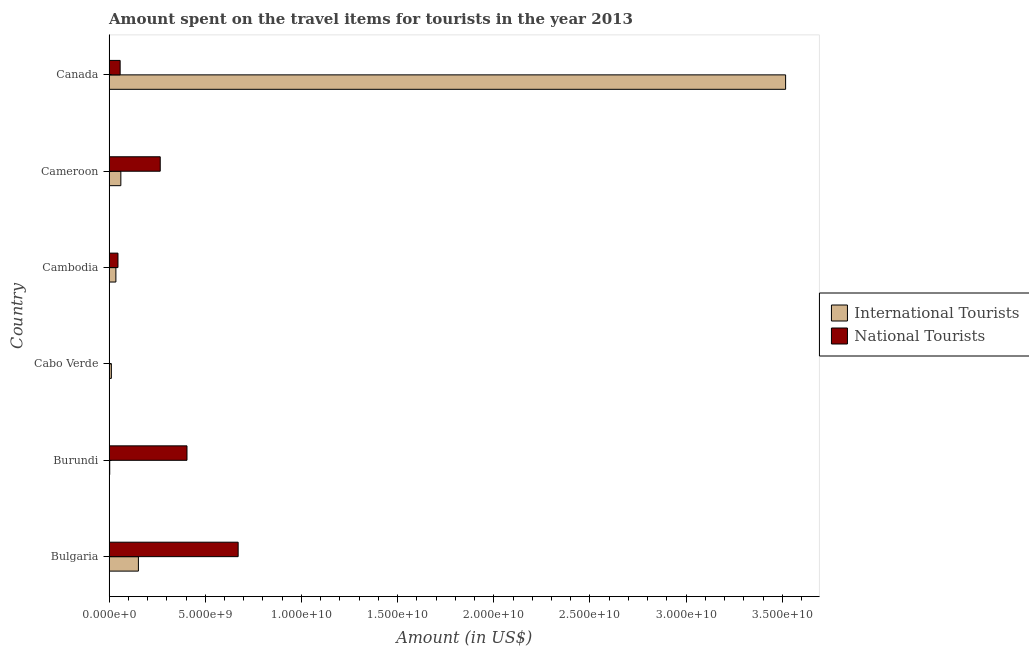How many different coloured bars are there?
Make the answer very short. 2. How many groups of bars are there?
Your response must be concise. 6. Are the number of bars per tick equal to the number of legend labels?
Provide a short and direct response. Yes. What is the label of the 3rd group of bars from the top?
Offer a terse response. Cambodia. In how many cases, is the number of bars for a given country not equal to the number of legend labels?
Give a very brief answer. 0. What is the amount spent on travel items of international tourists in Cameroon?
Offer a terse response. 6.12e+08. Across all countries, what is the maximum amount spent on travel items of national tourists?
Provide a succinct answer. 6.71e+09. Across all countries, what is the minimum amount spent on travel items of international tourists?
Offer a terse response. 3.40e+07. In which country was the amount spent on travel items of international tourists maximum?
Keep it short and to the point. Canada. In which country was the amount spent on travel items of international tourists minimum?
Offer a very short reply. Burundi. What is the total amount spent on travel items of international tourists in the graph?
Offer a terse response. 3.78e+1. What is the difference between the amount spent on travel items of international tourists in Cabo Verde and that in Cambodia?
Provide a short and direct response. -2.36e+08. What is the difference between the amount spent on travel items of international tourists in Bulgaria and the amount spent on travel items of national tourists in Cabo Verde?
Provide a short and direct response. 1.52e+09. What is the average amount spent on travel items of international tourists per country?
Provide a succinct answer. 6.30e+09. What is the difference between the amount spent on travel items of national tourists and amount spent on travel items of international tourists in Canada?
Keep it short and to the point. -3.46e+1. What is the difference between the highest and the second highest amount spent on travel items of national tourists?
Keep it short and to the point. 2.66e+09. What is the difference between the highest and the lowest amount spent on travel items of international tourists?
Provide a succinct answer. 3.51e+1. What does the 1st bar from the top in Burundi represents?
Give a very brief answer. National Tourists. What does the 2nd bar from the bottom in Burundi represents?
Keep it short and to the point. National Tourists. Are all the bars in the graph horizontal?
Give a very brief answer. Yes. What is the difference between two consecutive major ticks on the X-axis?
Keep it short and to the point. 5.00e+09. Does the graph contain any zero values?
Keep it short and to the point. No. Does the graph contain grids?
Give a very brief answer. No. Where does the legend appear in the graph?
Your answer should be compact. Center right. What is the title of the graph?
Your answer should be compact. Amount spent on the travel items for tourists in the year 2013. What is the label or title of the Y-axis?
Your answer should be very brief. Country. What is the Amount (in US$) of International Tourists in Bulgaria?
Make the answer very short. 1.52e+09. What is the Amount (in US$) in National Tourists in Bulgaria?
Keep it short and to the point. 6.71e+09. What is the Amount (in US$) in International Tourists in Burundi?
Offer a terse response. 3.40e+07. What is the Amount (in US$) in National Tourists in Burundi?
Your answer should be compact. 4.05e+09. What is the Amount (in US$) in International Tourists in Cabo Verde?
Your answer should be very brief. 1.19e+08. What is the Amount (in US$) of National Tourists in Cabo Verde?
Offer a very short reply. 2.29e+06. What is the Amount (in US$) in International Tourists in Cambodia?
Your answer should be very brief. 3.55e+08. What is the Amount (in US$) in National Tourists in Cambodia?
Make the answer very short. 4.63e+08. What is the Amount (in US$) in International Tourists in Cameroon?
Make the answer very short. 6.12e+08. What is the Amount (in US$) in National Tourists in Cameroon?
Give a very brief answer. 2.66e+09. What is the Amount (in US$) in International Tourists in Canada?
Give a very brief answer. 3.52e+1. What is the Amount (in US$) in National Tourists in Canada?
Provide a succinct answer. 5.76e+08. Across all countries, what is the maximum Amount (in US$) of International Tourists?
Make the answer very short. 3.52e+1. Across all countries, what is the maximum Amount (in US$) of National Tourists?
Make the answer very short. 6.71e+09. Across all countries, what is the minimum Amount (in US$) in International Tourists?
Ensure brevity in your answer.  3.40e+07. Across all countries, what is the minimum Amount (in US$) of National Tourists?
Provide a succinct answer. 2.29e+06. What is the total Amount (in US$) of International Tourists in the graph?
Give a very brief answer. 3.78e+1. What is the total Amount (in US$) in National Tourists in the graph?
Your answer should be compact. 1.45e+1. What is the difference between the Amount (in US$) of International Tourists in Bulgaria and that in Burundi?
Provide a short and direct response. 1.49e+09. What is the difference between the Amount (in US$) in National Tourists in Bulgaria and that in Burundi?
Ensure brevity in your answer.  2.66e+09. What is the difference between the Amount (in US$) in International Tourists in Bulgaria and that in Cabo Verde?
Offer a terse response. 1.41e+09. What is the difference between the Amount (in US$) in National Tourists in Bulgaria and that in Cabo Verde?
Your answer should be compact. 6.71e+09. What is the difference between the Amount (in US$) in International Tourists in Bulgaria and that in Cambodia?
Your response must be concise. 1.17e+09. What is the difference between the Amount (in US$) in National Tourists in Bulgaria and that in Cambodia?
Give a very brief answer. 6.25e+09. What is the difference between the Amount (in US$) of International Tourists in Bulgaria and that in Cameroon?
Make the answer very short. 9.13e+08. What is the difference between the Amount (in US$) in National Tourists in Bulgaria and that in Cameroon?
Offer a very short reply. 4.05e+09. What is the difference between the Amount (in US$) of International Tourists in Bulgaria and that in Canada?
Your answer should be compact. -3.36e+1. What is the difference between the Amount (in US$) in National Tourists in Bulgaria and that in Canada?
Keep it short and to the point. 6.14e+09. What is the difference between the Amount (in US$) of International Tourists in Burundi and that in Cabo Verde?
Provide a short and direct response. -8.50e+07. What is the difference between the Amount (in US$) of National Tourists in Burundi and that in Cabo Verde?
Make the answer very short. 4.05e+09. What is the difference between the Amount (in US$) in International Tourists in Burundi and that in Cambodia?
Provide a succinct answer. -3.21e+08. What is the difference between the Amount (in US$) of National Tourists in Burundi and that in Cambodia?
Keep it short and to the point. 3.59e+09. What is the difference between the Amount (in US$) of International Tourists in Burundi and that in Cameroon?
Offer a very short reply. -5.78e+08. What is the difference between the Amount (in US$) of National Tourists in Burundi and that in Cameroon?
Your response must be concise. 1.39e+09. What is the difference between the Amount (in US$) in International Tourists in Burundi and that in Canada?
Keep it short and to the point. -3.51e+1. What is the difference between the Amount (in US$) of National Tourists in Burundi and that in Canada?
Offer a very short reply. 3.48e+09. What is the difference between the Amount (in US$) in International Tourists in Cabo Verde and that in Cambodia?
Give a very brief answer. -2.36e+08. What is the difference between the Amount (in US$) in National Tourists in Cabo Verde and that in Cambodia?
Offer a very short reply. -4.61e+08. What is the difference between the Amount (in US$) in International Tourists in Cabo Verde and that in Cameroon?
Provide a short and direct response. -4.93e+08. What is the difference between the Amount (in US$) of National Tourists in Cabo Verde and that in Cameroon?
Provide a succinct answer. -2.66e+09. What is the difference between the Amount (in US$) in International Tourists in Cabo Verde and that in Canada?
Offer a very short reply. -3.51e+1. What is the difference between the Amount (in US$) of National Tourists in Cabo Verde and that in Canada?
Give a very brief answer. -5.74e+08. What is the difference between the Amount (in US$) of International Tourists in Cambodia and that in Cameroon?
Your answer should be compact. -2.57e+08. What is the difference between the Amount (in US$) in National Tourists in Cambodia and that in Cameroon?
Your answer should be compact. -2.20e+09. What is the difference between the Amount (in US$) in International Tourists in Cambodia and that in Canada?
Your answer should be compact. -3.48e+1. What is the difference between the Amount (in US$) of National Tourists in Cambodia and that in Canada?
Provide a short and direct response. -1.13e+08. What is the difference between the Amount (in US$) in International Tourists in Cameroon and that in Canada?
Your answer should be very brief. -3.46e+1. What is the difference between the Amount (in US$) in National Tourists in Cameroon and that in Canada?
Ensure brevity in your answer.  2.08e+09. What is the difference between the Amount (in US$) of International Tourists in Bulgaria and the Amount (in US$) of National Tourists in Burundi?
Keep it short and to the point. -2.53e+09. What is the difference between the Amount (in US$) of International Tourists in Bulgaria and the Amount (in US$) of National Tourists in Cabo Verde?
Provide a succinct answer. 1.52e+09. What is the difference between the Amount (in US$) in International Tourists in Bulgaria and the Amount (in US$) in National Tourists in Cambodia?
Your response must be concise. 1.06e+09. What is the difference between the Amount (in US$) in International Tourists in Bulgaria and the Amount (in US$) in National Tourists in Cameroon?
Your response must be concise. -1.14e+09. What is the difference between the Amount (in US$) of International Tourists in Bulgaria and the Amount (in US$) of National Tourists in Canada?
Your answer should be very brief. 9.49e+08. What is the difference between the Amount (in US$) in International Tourists in Burundi and the Amount (in US$) in National Tourists in Cabo Verde?
Ensure brevity in your answer.  3.17e+07. What is the difference between the Amount (in US$) of International Tourists in Burundi and the Amount (in US$) of National Tourists in Cambodia?
Give a very brief answer. -4.29e+08. What is the difference between the Amount (in US$) in International Tourists in Burundi and the Amount (in US$) in National Tourists in Cameroon?
Make the answer very short. -2.63e+09. What is the difference between the Amount (in US$) of International Tourists in Burundi and the Amount (in US$) of National Tourists in Canada?
Make the answer very short. -5.42e+08. What is the difference between the Amount (in US$) of International Tourists in Cabo Verde and the Amount (in US$) of National Tourists in Cambodia?
Ensure brevity in your answer.  -3.44e+08. What is the difference between the Amount (in US$) of International Tourists in Cabo Verde and the Amount (in US$) of National Tourists in Cameroon?
Your response must be concise. -2.54e+09. What is the difference between the Amount (in US$) of International Tourists in Cabo Verde and the Amount (in US$) of National Tourists in Canada?
Offer a very short reply. -4.57e+08. What is the difference between the Amount (in US$) of International Tourists in Cambodia and the Amount (in US$) of National Tourists in Cameroon?
Keep it short and to the point. -2.30e+09. What is the difference between the Amount (in US$) in International Tourists in Cambodia and the Amount (in US$) in National Tourists in Canada?
Provide a succinct answer. -2.21e+08. What is the difference between the Amount (in US$) of International Tourists in Cameroon and the Amount (in US$) of National Tourists in Canada?
Your answer should be very brief. 3.60e+07. What is the average Amount (in US$) of International Tourists per country?
Your response must be concise. 6.30e+09. What is the average Amount (in US$) in National Tourists per country?
Give a very brief answer. 2.41e+09. What is the difference between the Amount (in US$) of International Tourists and Amount (in US$) of National Tourists in Bulgaria?
Offer a very short reply. -5.19e+09. What is the difference between the Amount (in US$) in International Tourists and Amount (in US$) in National Tourists in Burundi?
Your answer should be compact. -4.02e+09. What is the difference between the Amount (in US$) of International Tourists and Amount (in US$) of National Tourists in Cabo Verde?
Ensure brevity in your answer.  1.17e+08. What is the difference between the Amount (in US$) in International Tourists and Amount (in US$) in National Tourists in Cambodia?
Provide a short and direct response. -1.08e+08. What is the difference between the Amount (in US$) of International Tourists and Amount (in US$) of National Tourists in Cameroon?
Offer a very short reply. -2.05e+09. What is the difference between the Amount (in US$) of International Tourists and Amount (in US$) of National Tourists in Canada?
Provide a succinct answer. 3.46e+1. What is the ratio of the Amount (in US$) in International Tourists in Bulgaria to that in Burundi?
Make the answer very short. 44.85. What is the ratio of the Amount (in US$) in National Tourists in Bulgaria to that in Burundi?
Make the answer very short. 1.66. What is the ratio of the Amount (in US$) in International Tourists in Bulgaria to that in Cabo Verde?
Keep it short and to the point. 12.82. What is the ratio of the Amount (in US$) of National Tourists in Bulgaria to that in Cabo Verde?
Keep it short and to the point. 2930.57. What is the ratio of the Amount (in US$) of International Tourists in Bulgaria to that in Cambodia?
Offer a very short reply. 4.3. What is the ratio of the Amount (in US$) of National Tourists in Bulgaria to that in Cambodia?
Provide a succinct answer. 14.49. What is the ratio of the Amount (in US$) in International Tourists in Bulgaria to that in Cameroon?
Give a very brief answer. 2.49. What is the ratio of the Amount (in US$) of National Tourists in Bulgaria to that in Cameroon?
Make the answer very short. 2.52. What is the ratio of the Amount (in US$) in International Tourists in Bulgaria to that in Canada?
Offer a terse response. 0.04. What is the ratio of the Amount (in US$) in National Tourists in Bulgaria to that in Canada?
Make the answer very short. 11.65. What is the ratio of the Amount (in US$) of International Tourists in Burundi to that in Cabo Verde?
Offer a terse response. 0.29. What is the ratio of the Amount (in US$) of National Tourists in Burundi to that in Cabo Verde?
Ensure brevity in your answer.  1769. What is the ratio of the Amount (in US$) in International Tourists in Burundi to that in Cambodia?
Provide a short and direct response. 0.1. What is the ratio of the Amount (in US$) in National Tourists in Burundi to that in Cambodia?
Your answer should be compact. 8.75. What is the ratio of the Amount (in US$) in International Tourists in Burundi to that in Cameroon?
Offer a very short reply. 0.06. What is the ratio of the Amount (in US$) in National Tourists in Burundi to that in Cameroon?
Your answer should be very brief. 1.52. What is the ratio of the Amount (in US$) in International Tourists in Burundi to that in Canada?
Provide a short and direct response. 0. What is the ratio of the Amount (in US$) of National Tourists in Burundi to that in Canada?
Your answer should be compact. 7.03. What is the ratio of the Amount (in US$) of International Tourists in Cabo Verde to that in Cambodia?
Give a very brief answer. 0.34. What is the ratio of the Amount (in US$) in National Tourists in Cabo Verde to that in Cambodia?
Give a very brief answer. 0. What is the ratio of the Amount (in US$) of International Tourists in Cabo Verde to that in Cameroon?
Your response must be concise. 0.19. What is the ratio of the Amount (in US$) in National Tourists in Cabo Verde to that in Cameroon?
Provide a short and direct response. 0. What is the ratio of the Amount (in US$) of International Tourists in Cabo Verde to that in Canada?
Ensure brevity in your answer.  0. What is the ratio of the Amount (in US$) of National Tourists in Cabo Verde to that in Canada?
Keep it short and to the point. 0. What is the ratio of the Amount (in US$) in International Tourists in Cambodia to that in Cameroon?
Keep it short and to the point. 0.58. What is the ratio of the Amount (in US$) in National Tourists in Cambodia to that in Cameroon?
Your response must be concise. 0.17. What is the ratio of the Amount (in US$) of International Tourists in Cambodia to that in Canada?
Keep it short and to the point. 0.01. What is the ratio of the Amount (in US$) in National Tourists in Cambodia to that in Canada?
Offer a terse response. 0.8. What is the ratio of the Amount (in US$) in International Tourists in Cameroon to that in Canada?
Ensure brevity in your answer.  0.02. What is the ratio of the Amount (in US$) in National Tourists in Cameroon to that in Canada?
Give a very brief answer. 4.62. What is the difference between the highest and the second highest Amount (in US$) of International Tourists?
Provide a short and direct response. 3.36e+1. What is the difference between the highest and the second highest Amount (in US$) in National Tourists?
Offer a terse response. 2.66e+09. What is the difference between the highest and the lowest Amount (in US$) in International Tourists?
Ensure brevity in your answer.  3.51e+1. What is the difference between the highest and the lowest Amount (in US$) in National Tourists?
Provide a short and direct response. 6.71e+09. 